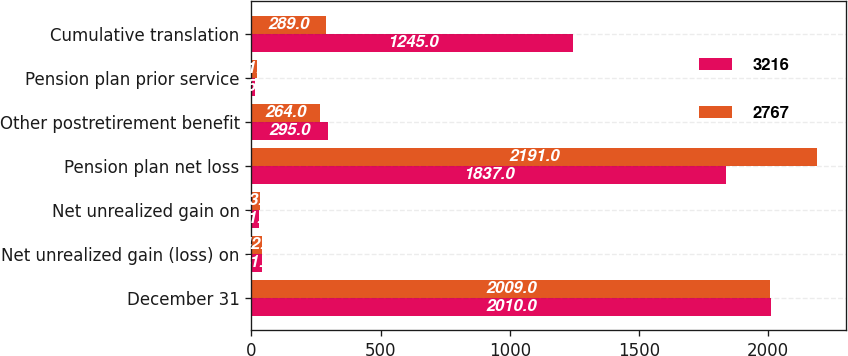Convert chart. <chart><loc_0><loc_0><loc_500><loc_500><stacked_bar_chart><ecel><fcel>December 31<fcel>Net unrealized gain (loss) on<fcel>Net unrealized gain on<fcel>Pension plan net loss<fcel>Other postretirement benefit<fcel>Pension plan prior service<fcel>Cumulative translation<nl><fcel>3216<fcel>2010<fcel>41<fcel>31<fcel>1837<fcel>295<fcel>15<fcel>1245<nl><fcel>2767<fcel>2009<fcel>42<fcel>33<fcel>2191<fcel>264<fcel>21<fcel>289<nl></chart> 